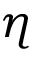Convert formula to latex. <formula><loc_0><loc_0><loc_500><loc_500>\eta</formula> 